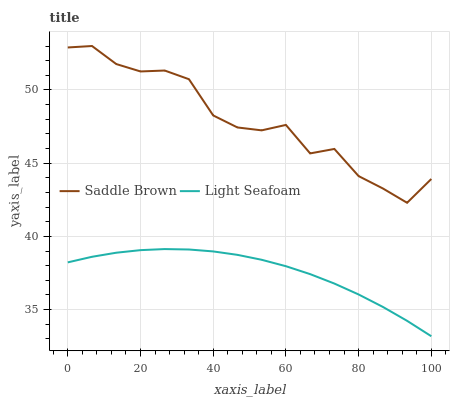Does Light Seafoam have the minimum area under the curve?
Answer yes or no. Yes. Does Saddle Brown have the maximum area under the curve?
Answer yes or no. Yes. Does Saddle Brown have the minimum area under the curve?
Answer yes or no. No. Is Light Seafoam the smoothest?
Answer yes or no. Yes. Is Saddle Brown the roughest?
Answer yes or no. Yes. Is Saddle Brown the smoothest?
Answer yes or no. No. Does Light Seafoam have the lowest value?
Answer yes or no. Yes. Does Saddle Brown have the lowest value?
Answer yes or no. No. Does Saddle Brown have the highest value?
Answer yes or no. Yes. Is Light Seafoam less than Saddle Brown?
Answer yes or no. Yes. Is Saddle Brown greater than Light Seafoam?
Answer yes or no. Yes. Does Light Seafoam intersect Saddle Brown?
Answer yes or no. No. 